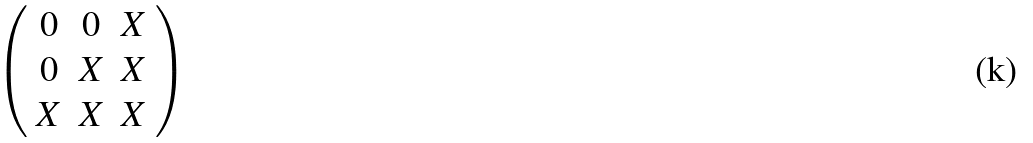<formula> <loc_0><loc_0><loc_500><loc_500>\left ( \begin{array} { c c c } { 0 } & { 0 } & { X } \\ { 0 } & { X } & { X } \\ { X } & { X } & { X } \end{array} \right )</formula> 